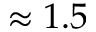Convert formula to latex. <formula><loc_0><loc_0><loc_500><loc_500>\approx 1 . 5</formula> 